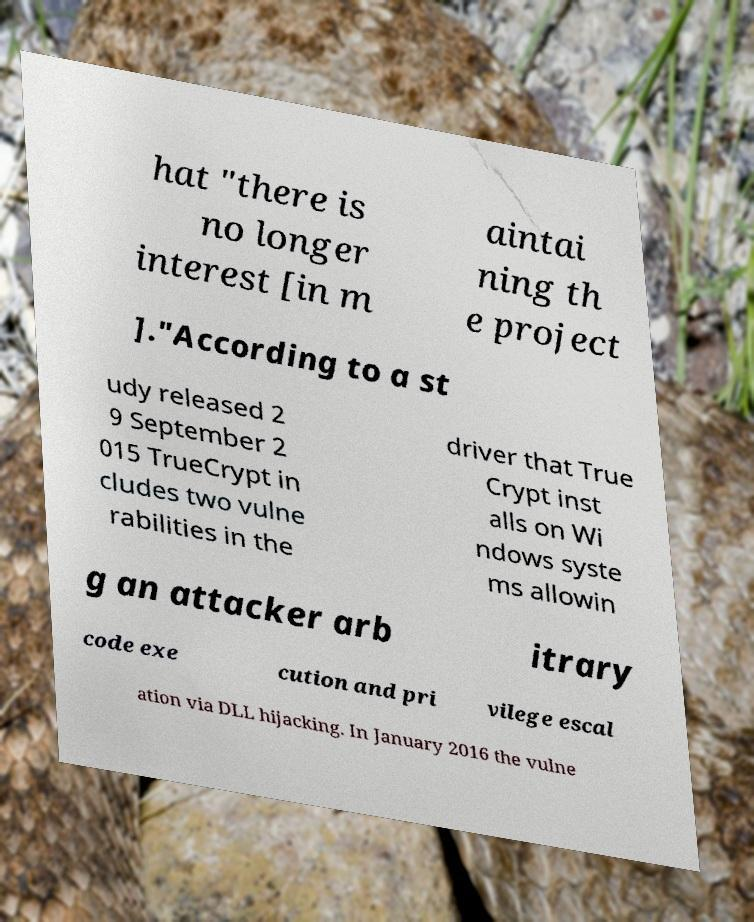Could you extract and type out the text from this image? hat "there is no longer interest [in m aintai ning th e project ]."According to a st udy released 2 9 September 2 015 TrueCrypt in cludes two vulne rabilities in the driver that True Crypt inst alls on Wi ndows syste ms allowin g an attacker arb itrary code exe cution and pri vilege escal ation via DLL hijacking. In January 2016 the vulne 